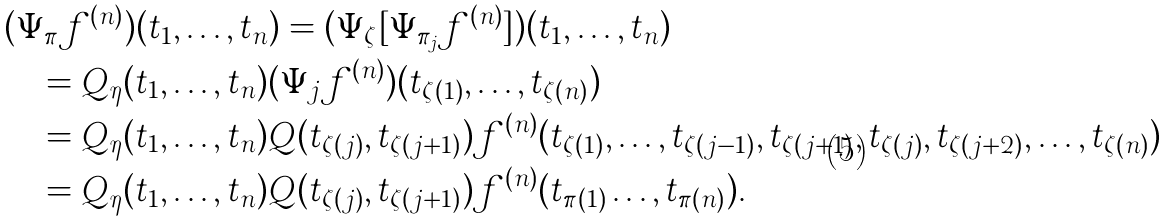Convert formula to latex. <formula><loc_0><loc_0><loc_500><loc_500>& ( \Psi _ { \pi } f ^ { ( n ) } ) ( t _ { 1 } , \dots , t _ { n } ) = ( \Psi _ { \zeta } [ \Psi _ { \pi _ { j } } f ^ { ( n ) } ] ) ( t _ { 1 } , \dots , t _ { n } ) \\ & \quad = Q _ { \eta } ( t _ { 1 } , \dots , t _ { n } ) ( \Psi _ { j } f ^ { ( n ) } ) ( t _ { \zeta ( 1 ) } , \dots , t _ { \zeta ( n ) } ) \\ & \quad = Q _ { \eta } ( t _ { 1 } , \dots , t _ { n } ) Q ( t _ { \zeta ( j ) } , t _ { \zeta ( j + 1 ) } ) f ^ { ( n ) } ( t _ { \zeta ( 1 ) } , \dots , t _ { \zeta ( j - 1 ) } , t _ { \zeta ( j + 1 ) } , t _ { \zeta ( j ) } , t _ { \zeta ( j + 2 ) } , \dots , t _ { \zeta ( n ) } ) \\ & \quad = Q _ { \eta } ( t _ { 1 } , \dots , t _ { n } ) Q ( t _ { \zeta ( j ) } , t _ { \zeta ( j + 1 ) } ) f ^ { ( n ) } ( t _ { \pi ( 1 ) } \dots , t _ { \pi ( n ) } ) .</formula> 